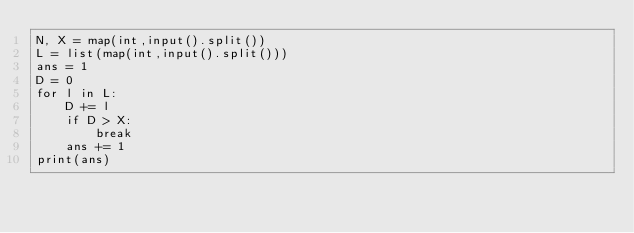<code> <loc_0><loc_0><loc_500><loc_500><_Python_>N, X = map(int,input().split())
L = list(map(int,input().split()))
ans = 1
D = 0
for l in L:
	D += l
	if D > X:
		break
	ans += 1
print(ans)</code> 